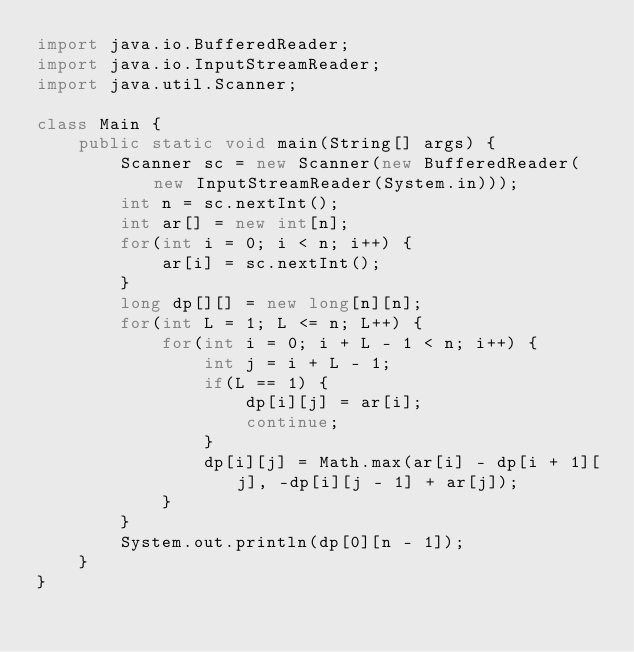Convert code to text. <code><loc_0><loc_0><loc_500><loc_500><_Java_>import java.io.BufferedReader;
import java.io.InputStreamReader;
import java.util.Scanner;

class Main {
    public static void main(String[] args) {
        Scanner sc = new Scanner(new BufferedReader(new InputStreamReader(System.in)));
        int n = sc.nextInt();
        int ar[] = new int[n];
        for(int i = 0; i < n; i++) {
            ar[i] = sc.nextInt();
        }
        long dp[][] = new long[n][n];
        for(int L = 1; L <= n; L++) {
            for(int i = 0; i + L - 1 < n; i++) {
                int j = i + L - 1;
                if(L == 1) {
                    dp[i][j] = ar[i];
                    continue;
                }
                dp[i][j] = Math.max(ar[i] - dp[i + 1][j], -dp[i][j - 1] + ar[j]);
            }
        }
        System.out.println(dp[0][n - 1]);
    }
}
</code> 